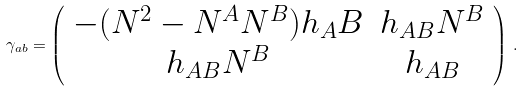Convert formula to latex. <formula><loc_0><loc_0><loc_500><loc_500>\gamma _ { a b } = \left ( \begin{array} { c c } - ( N ^ { 2 } - N ^ { A } N ^ { B } ) h _ { A } B & h _ { A B } N ^ { B } \\ h _ { A B } N ^ { B } & h _ { A B } \end{array} \right ) \, .</formula> 